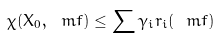<formula> <loc_0><loc_0><loc_500><loc_500>\chi ( X _ { 0 } , \ m f ) \leq \sum \gamma _ { i } r _ { i } ( \ m f )</formula> 